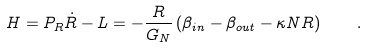Convert formula to latex. <formula><loc_0><loc_0><loc_500><loc_500>H = P _ { R } \dot { R } - L = - \frac { R } { G _ { N } } \left ( \beta _ { i n } - \beta _ { o u t } - \kappa N R \right ) \quad .</formula> 